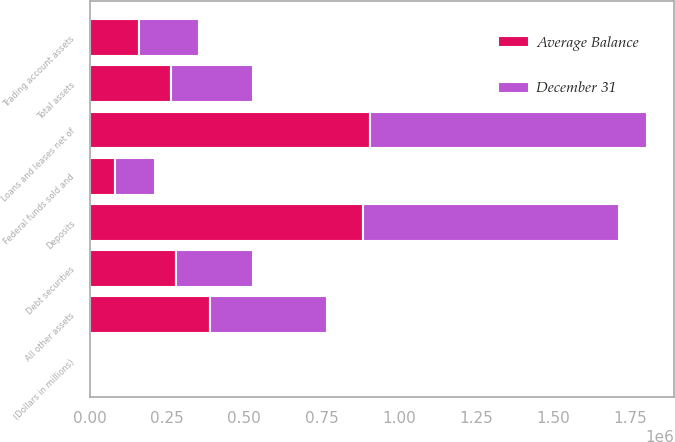<chart> <loc_0><loc_0><loc_500><loc_500><stacked_bar_chart><ecel><fcel>(Dollars in millions)<fcel>Federal funds sold and<fcel>Trading account assets<fcel>Debt securities<fcel>Loans and leases net of<fcel>All other assets<fcel>Total assets<fcel>Deposits<nl><fcel>Average Balance<fcel>2008<fcel>82478<fcel>159522<fcel>277589<fcel>908375<fcel>389979<fcel>264070<fcel>882997<nl><fcel>December 31<fcel>2008<fcel>128053<fcel>193631<fcel>250551<fcel>893353<fcel>378391<fcel>264070<fcel>831144<nl></chart> 